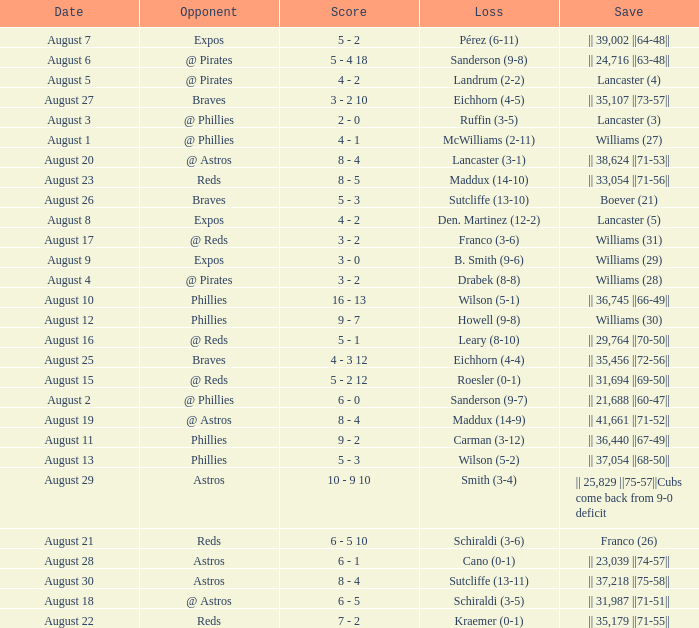Name the opponent with loss of sanderson (9-8) @ Pirates. 